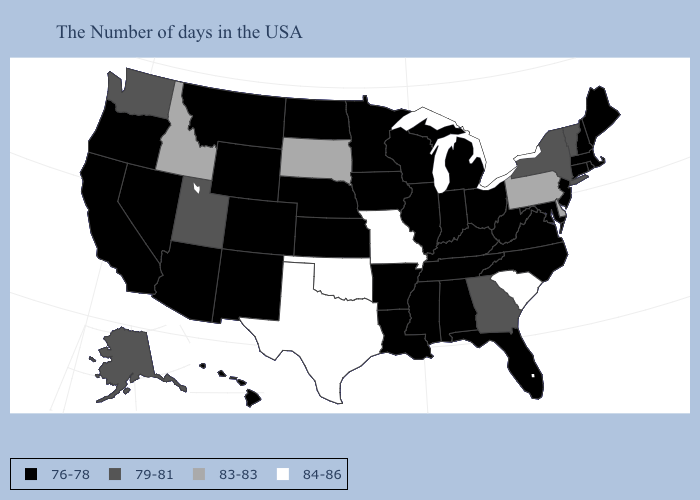Is the legend a continuous bar?
Keep it brief. No. What is the value of Wyoming?
Quick response, please. 76-78. Does South Carolina have the highest value in the South?
Quick response, please. Yes. Does Oklahoma have the lowest value in the USA?
Short answer required. No. What is the value of Montana?
Short answer required. 76-78. Does New Hampshire have a higher value than Maine?
Concise answer only. No. Does Delaware have a higher value than North Carolina?
Short answer required. Yes. What is the lowest value in the USA?
Give a very brief answer. 76-78. Name the states that have a value in the range 83-83?
Concise answer only. Delaware, Pennsylvania, South Dakota, Idaho. Name the states that have a value in the range 84-86?
Be succinct. South Carolina, Missouri, Oklahoma, Texas. What is the value of Delaware?
Quick response, please. 83-83. Name the states that have a value in the range 76-78?
Write a very short answer. Maine, Massachusetts, Rhode Island, New Hampshire, Connecticut, New Jersey, Maryland, Virginia, North Carolina, West Virginia, Ohio, Florida, Michigan, Kentucky, Indiana, Alabama, Tennessee, Wisconsin, Illinois, Mississippi, Louisiana, Arkansas, Minnesota, Iowa, Kansas, Nebraska, North Dakota, Wyoming, Colorado, New Mexico, Montana, Arizona, Nevada, California, Oregon, Hawaii. Name the states that have a value in the range 79-81?
Give a very brief answer. Vermont, New York, Georgia, Utah, Washington, Alaska. Does Virginia have a lower value than Vermont?
Be succinct. Yes. What is the lowest value in the West?
Answer briefly. 76-78. 